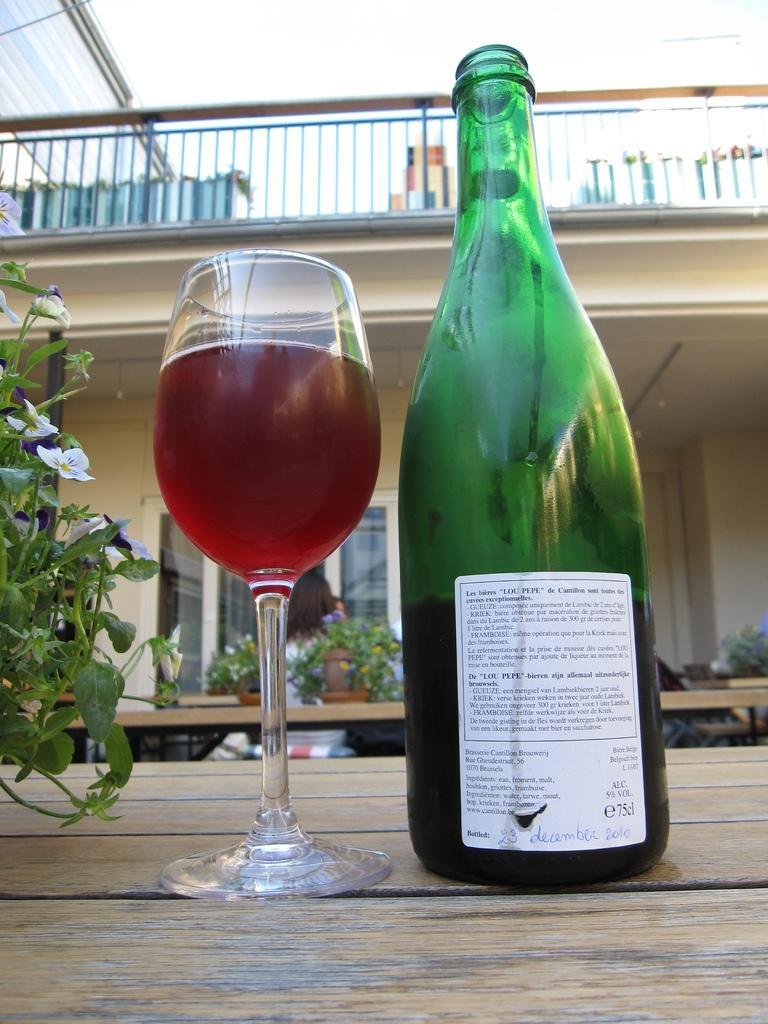In one or two sentences, can you explain what this image depicts? In this image there is a bottle and a glass filled with drink kept on a wooden table on the left side there are leaves of the plant. In the background there are house plants and woman is standing and a green white colour window and the building and there is a sky. 